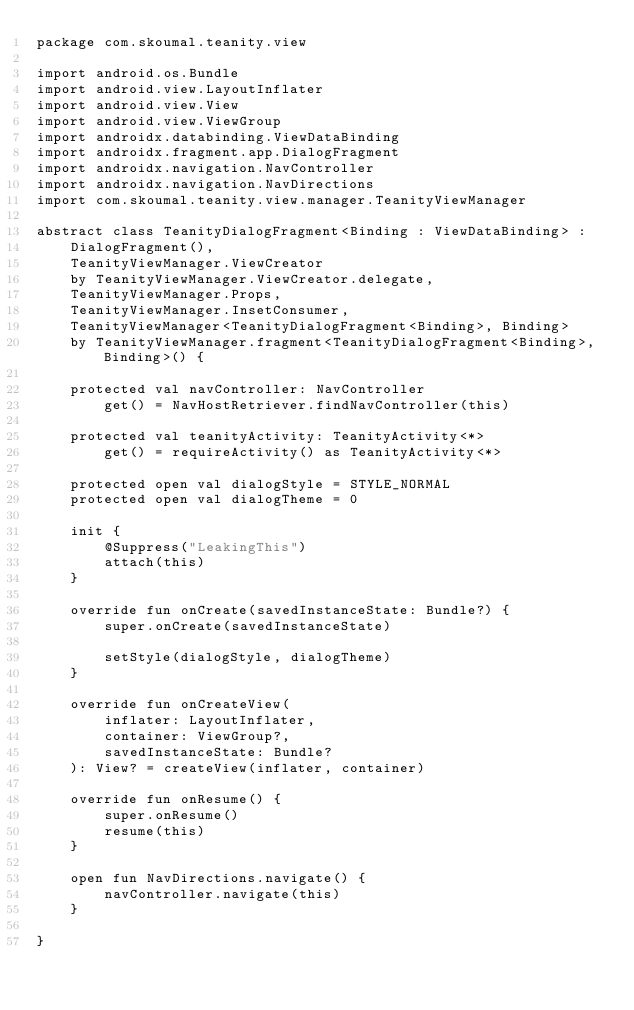<code> <loc_0><loc_0><loc_500><loc_500><_Kotlin_>package com.skoumal.teanity.view

import android.os.Bundle
import android.view.LayoutInflater
import android.view.View
import android.view.ViewGroup
import androidx.databinding.ViewDataBinding
import androidx.fragment.app.DialogFragment
import androidx.navigation.NavController
import androidx.navigation.NavDirections
import com.skoumal.teanity.view.manager.TeanityViewManager

abstract class TeanityDialogFragment<Binding : ViewDataBinding> :
    DialogFragment(),
    TeanityViewManager.ViewCreator
    by TeanityViewManager.ViewCreator.delegate,
    TeanityViewManager.Props,
    TeanityViewManager.InsetConsumer,
    TeanityViewManager<TeanityDialogFragment<Binding>, Binding>
    by TeanityViewManager.fragment<TeanityDialogFragment<Binding>, Binding>() {

    protected val navController: NavController
        get() = NavHostRetriever.findNavController(this)

    protected val teanityActivity: TeanityActivity<*>
        get() = requireActivity() as TeanityActivity<*>

    protected open val dialogStyle = STYLE_NORMAL
    protected open val dialogTheme = 0

    init {
        @Suppress("LeakingThis")
        attach(this)
    }

    override fun onCreate(savedInstanceState: Bundle?) {
        super.onCreate(savedInstanceState)

        setStyle(dialogStyle, dialogTheme)
    }

    override fun onCreateView(
        inflater: LayoutInflater,
        container: ViewGroup?,
        savedInstanceState: Bundle?
    ): View? = createView(inflater, container)

    override fun onResume() {
        super.onResume()
        resume(this)
    }

    open fun NavDirections.navigate() {
        navController.navigate(this)
    }

}
</code> 